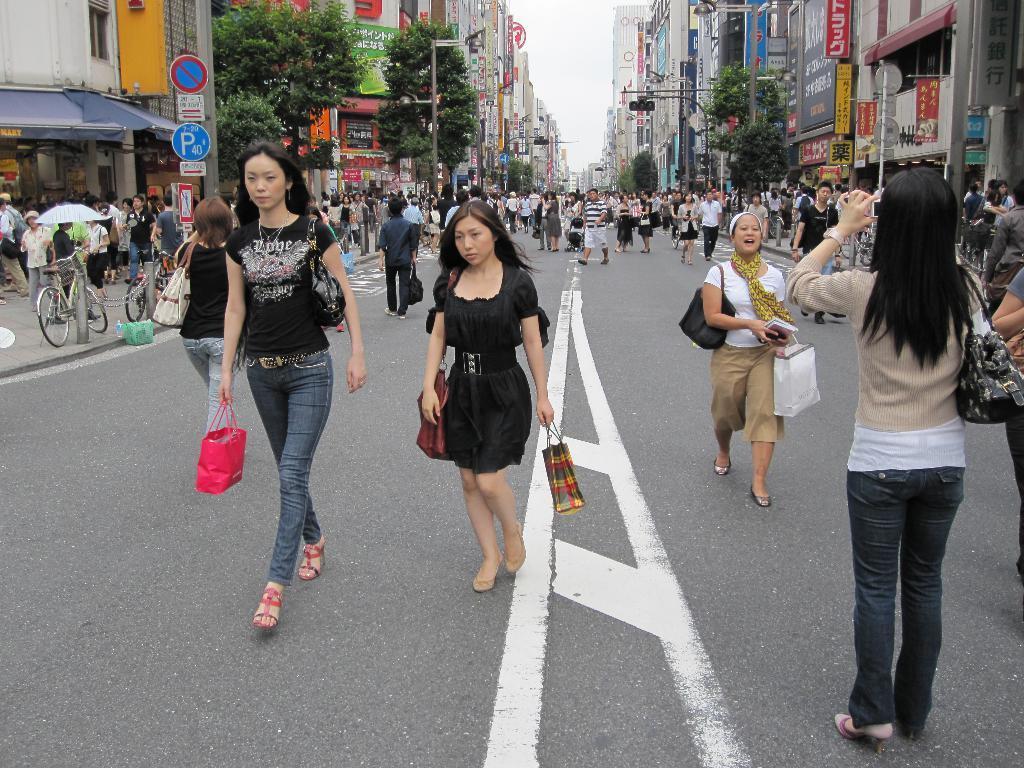Could you give a brief overview of what you see in this image? In the image there are many walking on the road and holding bags in their hands. In the background there are buildings with posters and banners. And also there are poles with street lights, traffic signals and sign boards. And also there are trees in the background. On the left side of the image there is a footpath with people, bicycles, poles and there is a building with store. 